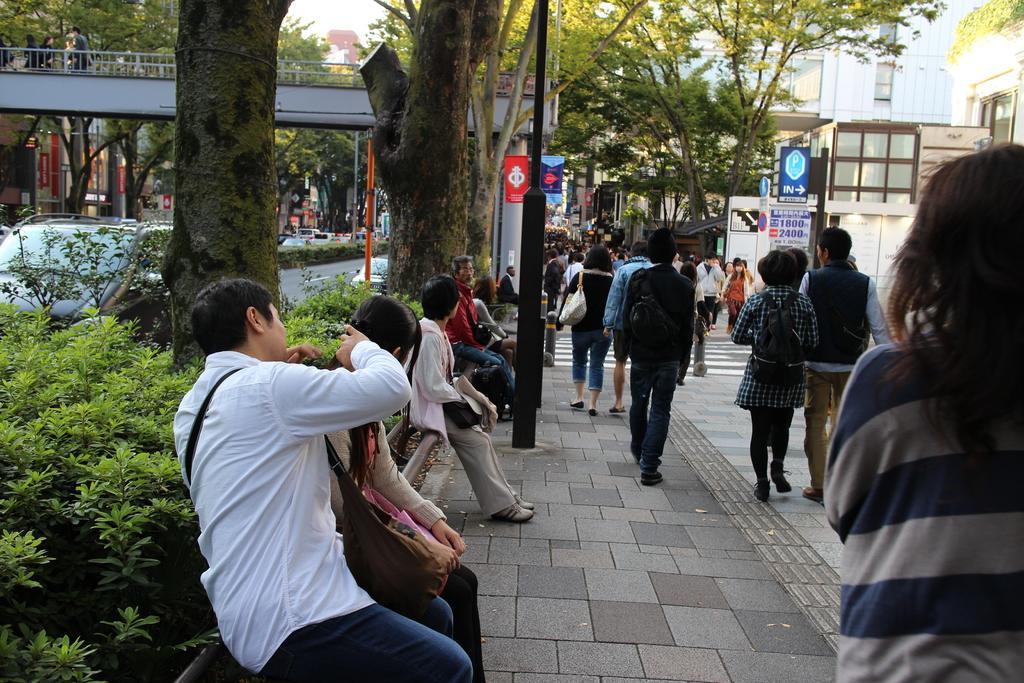In one or two sentences, can you explain what this image depicts? In this picture there is a person who is sitting on this pipe. Here we can see group of persons walking on the street and crossing the road. In the ground we can see buildings, trees and plants. Here we can see poster and sign boards. On the top there is a sky. Here we can see plants near to the vehicle. 